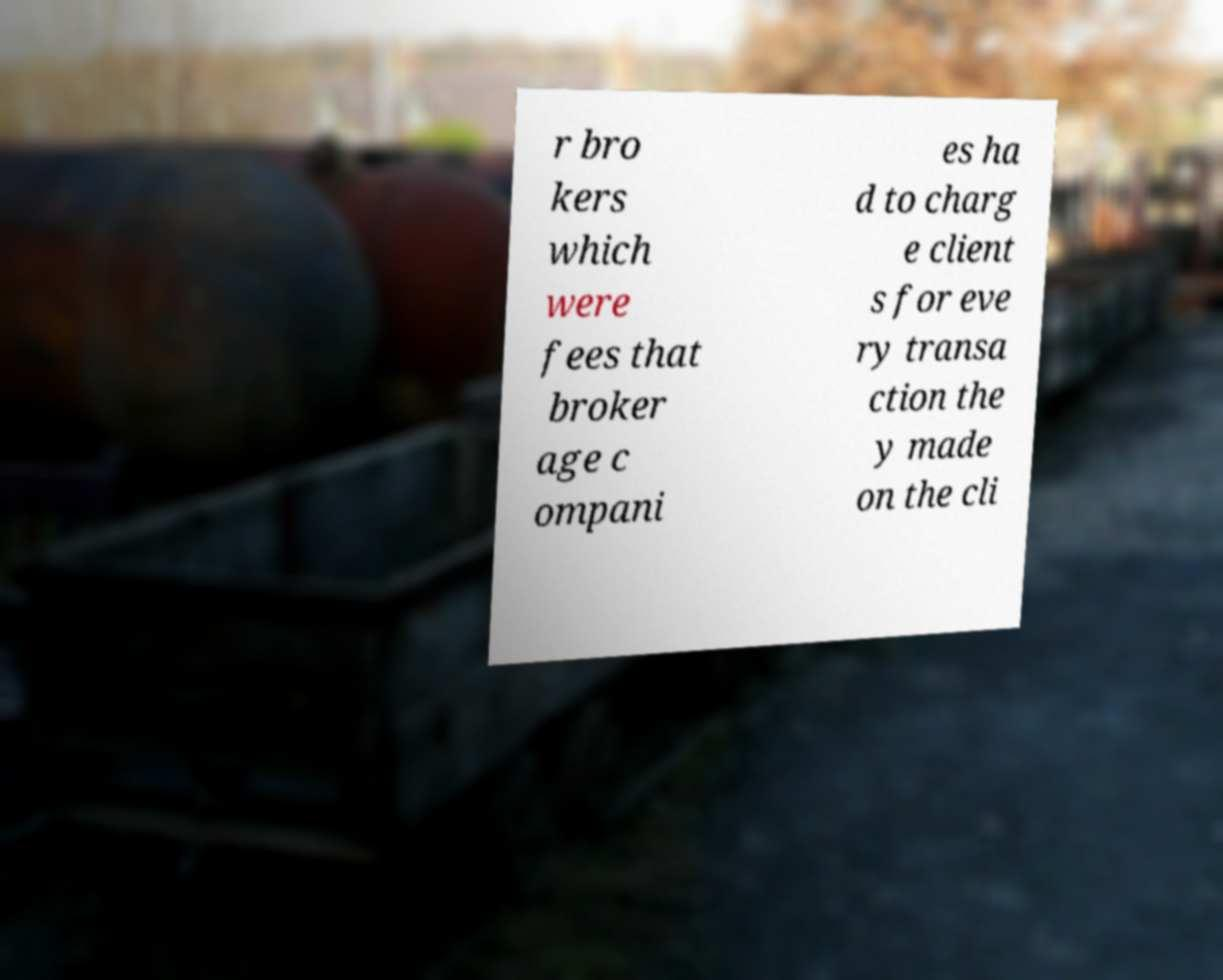Can you accurately transcribe the text from the provided image for me? r bro kers which were fees that broker age c ompani es ha d to charg e client s for eve ry transa ction the y made on the cli 